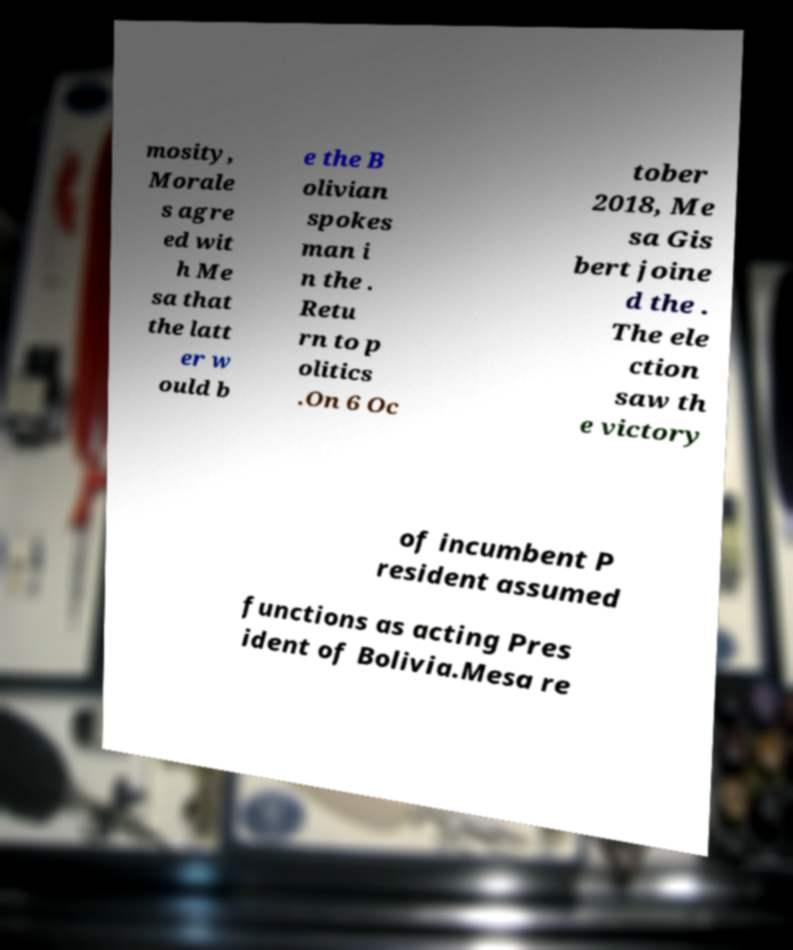Please identify and transcribe the text found in this image. mosity, Morale s agre ed wit h Me sa that the latt er w ould b e the B olivian spokes man i n the . Retu rn to p olitics .On 6 Oc tober 2018, Me sa Gis bert joine d the . The ele ction saw th e victory of incumbent P resident assumed functions as acting Pres ident of Bolivia.Mesa re 